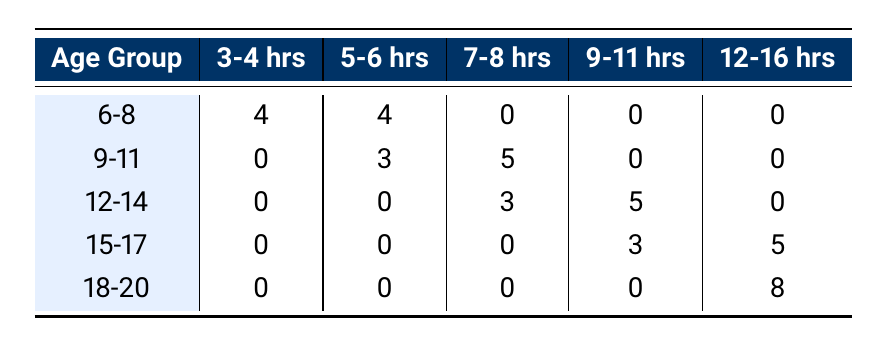What is the number of gymnasts in the 6-8 age group training 5-6 hours? The table shows that there are 4 gymnasts in the 6-8 age group training 5-6 hours.
Answer: 4 How many gymnasts in the 9-11 age group train for 7-8 hours? The table indicates that there are 5 gymnasts in the 9-11 age group training for 7-8 hours.
Answer: 5 Is there any gymnast in the 12-14 age group who trains for 12-16 hours? The table shows that there are 0 gymnasts in the 12-14 age group training for 12-16 hours.
Answer: No What is the total number of gymnasts training for 9-11 hours across all age groups? Adding the counts from the table: 0 (6-8) + 0 (9-11) + 5 (12-14) + 3 (15-17) + 0 (18-20) gives a total of 8 gymnasts.
Answer: 8 How many gymnasts aged 15-17 train for fewer than 12 hours? The table indicates that there are 3 gymnasts who train for 9-11 hours and 0 for 12-16 hours in the 15-17 age group, totaling 3 gymnasts.
Answer: 3 What percentage of gymnasts in the 18-20 age group train for 12-16 hours? There are 8 gymnasts in the 18-20 age group, all train for 12-16 hours. Thus, (8/8) * 100% = 100%.
Answer: 100% Which age group has the highest number of gymnasts training for 12-16 hours? The table shows that the 18-20 age group has 8 gymnasts training for 12-16 hours, which is more than any other age group.
Answer: 18-20 For gymnasts aged 12-14, what is the average training hours per week? The distribution shows 8 hours and above (7, 8, 9, 10, 10, 9, 11), summing to 79 hours across 8 gymnasts. Average = 79/8 = 9.875 -> rounded to 10.
Answer: 10 How many gymnasts across all age groups train for 3-4 hours? From the table, 4 (6-8) + 0 (9-11) + 0 (12-14) + 0 (15-17) + 0 (18-20) gives a total of 4 gymnasts training for 3-4 hours.
Answer: 4 